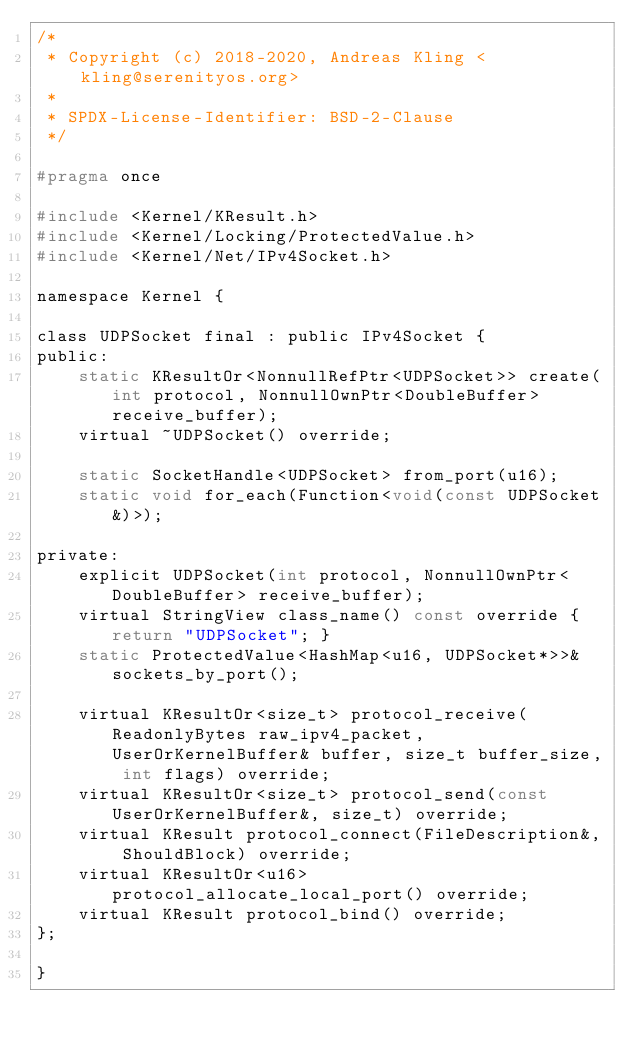<code> <loc_0><loc_0><loc_500><loc_500><_C_>/*
 * Copyright (c) 2018-2020, Andreas Kling <kling@serenityos.org>
 *
 * SPDX-License-Identifier: BSD-2-Clause
 */

#pragma once

#include <Kernel/KResult.h>
#include <Kernel/Locking/ProtectedValue.h>
#include <Kernel/Net/IPv4Socket.h>

namespace Kernel {

class UDPSocket final : public IPv4Socket {
public:
    static KResultOr<NonnullRefPtr<UDPSocket>> create(int protocol, NonnullOwnPtr<DoubleBuffer> receive_buffer);
    virtual ~UDPSocket() override;

    static SocketHandle<UDPSocket> from_port(u16);
    static void for_each(Function<void(const UDPSocket&)>);

private:
    explicit UDPSocket(int protocol, NonnullOwnPtr<DoubleBuffer> receive_buffer);
    virtual StringView class_name() const override { return "UDPSocket"; }
    static ProtectedValue<HashMap<u16, UDPSocket*>>& sockets_by_port();

    virtual KResultOr<size_t> protocol_receive(ReadonlyBytes raw_ipv4_packet, UserOrKernelBuffer& buffer, size_t buffer_size, int flags) override;
    virtual KResultOr<size_t> protocol_send(const UserOrKernelBuffer&, size_t) override;
    virtual KResult protocol_connect(FileDescription&, ShouldBlock) override;
    virtual KResultOr<u16> protocol_allocate_local_port() override;
    virtual KResult protocol_bind() override;
};

}
</code> 